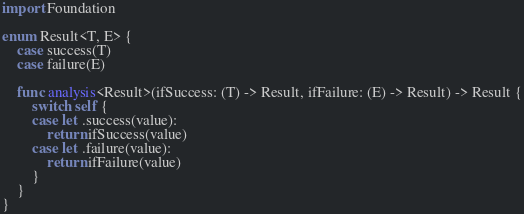<code> <loc_0><loc_0><loc_500><loc_500><_Swift_>import Foundation

enum Result<T, E> {
    case success(T)
    case failure(E)
    
    func analysis<Result>(ifSuccess: (T) -> Result, ifFailure: (E) -> Result) -> Result {
        switch self {
        case let .success(value):
            return ifSuccess(value)
        case let .failure(value):
            return ifFailure(value)
        }
    }
}
</code> 